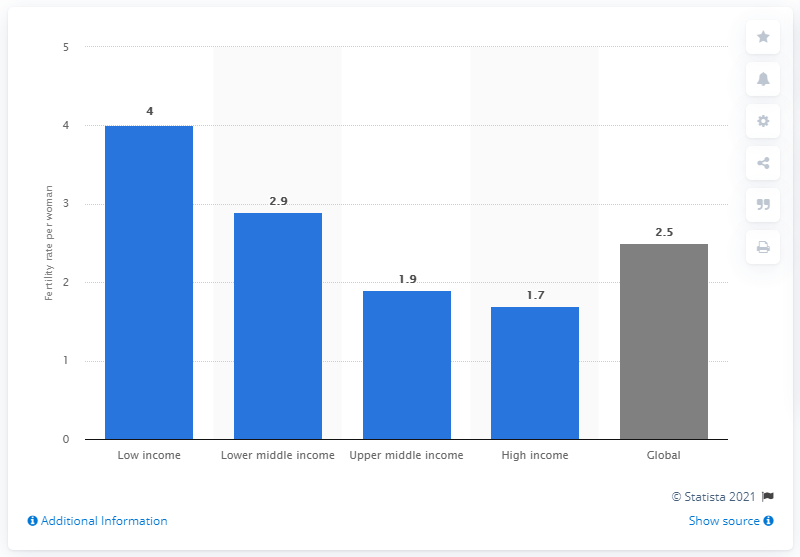Highlight a few significant elements in this photo. In 2012, the fertility rate in high income countries was 1.7. 